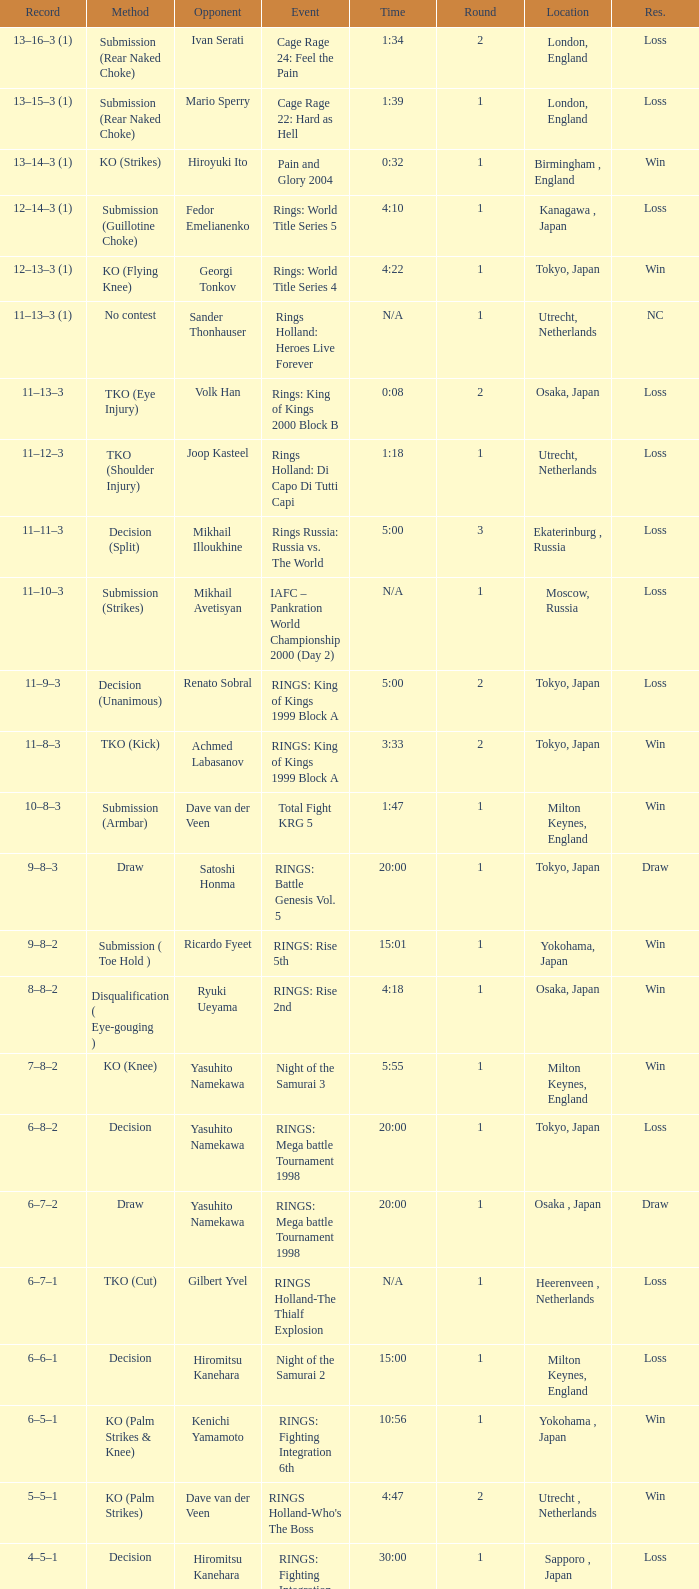What is the time for an opponent of Satoshi Honma? 20:00. 